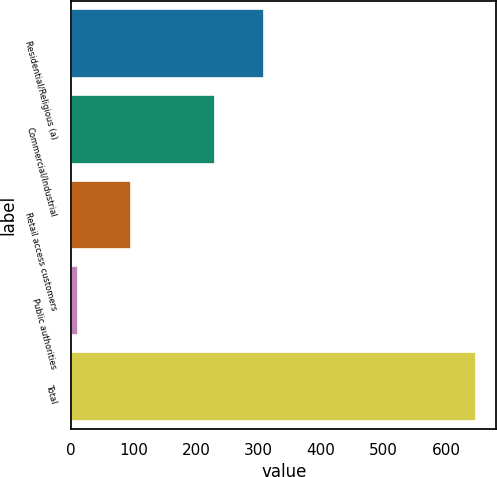Convert chart. <chart><loc_0><loc_0><loc_500><loc_500><bar_chart><fcel>Residential/Religious (a)<fcel>Commercial/Industrial<fcel>Retail access customers<fcel>Public authorities<fcel>Total<nl><fcel>309<fcel>231<fcel>95<fcel>11<fcel>648<nl></chart> 